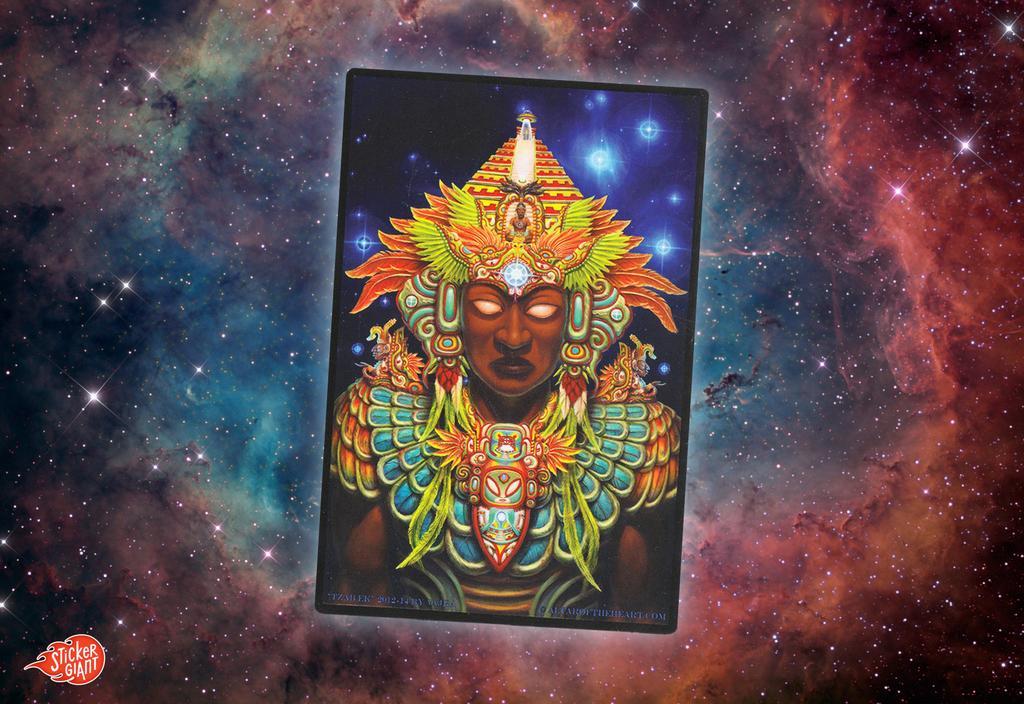Describe this image in one or two sentences. Here in this picture we can see an animated image, in which in the middle we can see a card with a sculpture of something present on it over there and we can see stars shining all around there. 